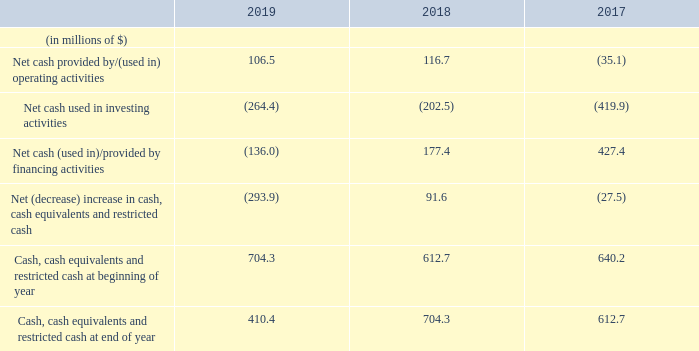Cash Flows
The following table summarizes our cash flows from operating, investing and financing activities for the periods indicated.
Net cash provided by/(used in) operating activities
Cash provided by operating activities decreased by $10.2 million to $106.5 million in 2019 compared to $116.7 million in 2018. The decrease was primarily due to:
• lower contribution recognized from our participation in the Cool Pool due to lower utilization and a higher number of drydocking days for our vessels for the year ended December 31, 2019;
• $24.9 million of drydocking costs as the majority of our fleet was scheduled for dry-dock during 2019;
• $9.3 million in cash receipts in connection with arbitration proceedings with a former charterer of the Golar Tundra, compared to $50.7 million recovered in 2018; and
• the reduction in the general timing of working capital in 2019 compared to the same period in 2018.
This was partially offset by receipts of $4.0 million in relation to a loss of hire insurance claim on the Golar Viking. There were no comparable receipts in 2018.
Cash provided by operating activities increased by $151.8 million to $116.7 million in 2018 compared to cash utilized of $35.1 million in 2017. The increase in cash utilized in 2018 was primarily due to: • higher contributions recognized from our participation in the Cool Pool as a result of improved utilization and daily hire rates from the Cool Pool vessels; • lower charterhire payments as a result of the expiry of the charter-back arrangement of the Golar Grand from Golar Partners in November 2017; • $50.7 million in cash receipts in connection with arbitration proceedings with a former charterer of the Golar Tundra; and • the improvement on the general timing of working capital in 2018 compared to the same period in 2017.
Net cash used in investing activities
Net cash used in investing activities of $264.4 million in 2019 comprised mainly of:
• $376.3 million of payments made in respect of the conversion of the Gimi into a FLNG;
• $21.0 million additional investments in Golar Power and Avenir; and
• $24.4 million of payments predominately for the installation of the ballast water treatment systems on eight of our vessels.
This was partially offset by receipts of:
• $115.2 million of proceeds from Keppel's initial subscription and subsequent cash calls in relation to its 30% equity interest in Gimi MS;
• $29.2 million of dividends received from Golar Partners; and
• $9.7 million of cash consideration received from Golar Partners in respect of the remaining net purchase price less working capital adjustments in connection with the Hilli acquisition.
Net cash used in investing activities of $202.5 million in 2018 comprised mainly of:
• the addition of $116.7 million to asset under development relating to payments made in respect of the conversion of the Hilli into a FLNG; and
• additions of $95.5 million to investments in affiliates, which relates principally to capital contributions made to Golar Power of $55.0 million and our investment in Avenir of $24.8 million; and
• additions to vessels and equipment of $33.1 million.
This was partially offset by: • receipt of $9.7 million from Golar Partners in relation to the Hilli Disposal; and • $33.2 million of dividends received from Golar Partners.
Net cash (used in)/provided by financing activities
Net cash used in financing activities is principally generated from funds from new debt, debt refinancings, debt repayments and cash dividends. Net cash used in financing activities of $136.0 million in 2019 arose primarily due to: • scheduled debt repayments of $443.1 million; • $100.0 million repayment of the Margin Loan following refinancing; • $9.1 million repayment upon the extension of the Golar Arctic facility; • payment of dividends of $65.0 million; • financing costs of $24.5 million predominately in relation to the Gimi debt facility; and • payment of $18.6 million in relation to the 1.5 million treasury shares repurchased on our equity swap in November 2019.
This was partially offset by debt proceeds drawn down of:
• $100.0 million on the new Margin Loan facility;
• $150.0 million on the term loan facility;
• $130.0 million on the Gimi facility; and
• $144.3 million in relation to our lessor VIE's.
Net cash provided by financing activities of $177.4 million in 2018 arose primarily due to proceeds of $1.2 billion from our debt facilities, including:
• $115.0 million further drawdown on the pre-delivery financing in relation to the conversion of the Hilli into a FLNG;
• $960.0 million drawdown on the post-acceptance Hilli sale and leaseback financing in relation to the Hilli Facility; and
• $101.0 million of debt proceeds drawn down by the lessor VIE, which owns the Golar Crystal, upon refinancing of its debt into a long-term loan facility. See note 5 "Variable Interest Entities" of our consolidated financial statements included herein.
This was partially offset by:
• loan repayments of $994.9 million, which includes (i) the repayment of $640.0 million on the pre-delivery financing in relation to the conversion of the Hilli into a FLNG, (ii) payment of $105.0 million in connection with the refinancing of the Golar Crystal facility mentioned above, (iii) payments of $76.9 million in connection with the Golar Tundra financing arrangement and (iv) scheduled repayments on our remaining debt facilities; and
• payment of dividends of $42.9 million.
What are the different components of cash flows? Net cash provided by/(used in) operating activities, net cash used in investing activities, net cash (used in)/provided by financing activities, net (decrease) increase in cash, cash equivalents and restricted cash. What was the amount of dividends received from Golar Partners in 2018? $33.2 million. What accounted for the higher contributions from the participation in Cool Pool? Improved utilization and daily hire rates from the cool pool vessels. In which year was the net cash provided by/(used in) operating activities the highest? 116.7 > 106.5 > (35.1)
Answer: 2018. What was the change in cash, cash equivalents and restricted cash at beginning of year from 2018 to 2019?
Answer scale should be: million. 704.3 - 612.7 
Answer: 91.6. What was the percentage change in cash, cash equivalents and restricted cash at end of year from 2017 to 2018?
Answer scale should be: percent. (704.3 - 612.7)/612.7 
Answer: 14.95. 